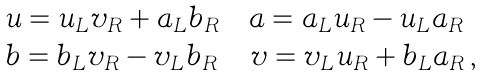<formula> <loc_0><loc_0><loc_500><loc_500>\begin{array} { l } u = u _ { L } v _ { R } + a _ { L } b _ { R } \quad a = a _ { L } u _ { R } - u _ { L } a _ { R } \\ b = b _ { L } v _ { R } - v _ { L } b _ { R } \, \quad v = v _ { L } u _ { R } + b _ { L } a _ { R } \, , \end{array}</formula> 